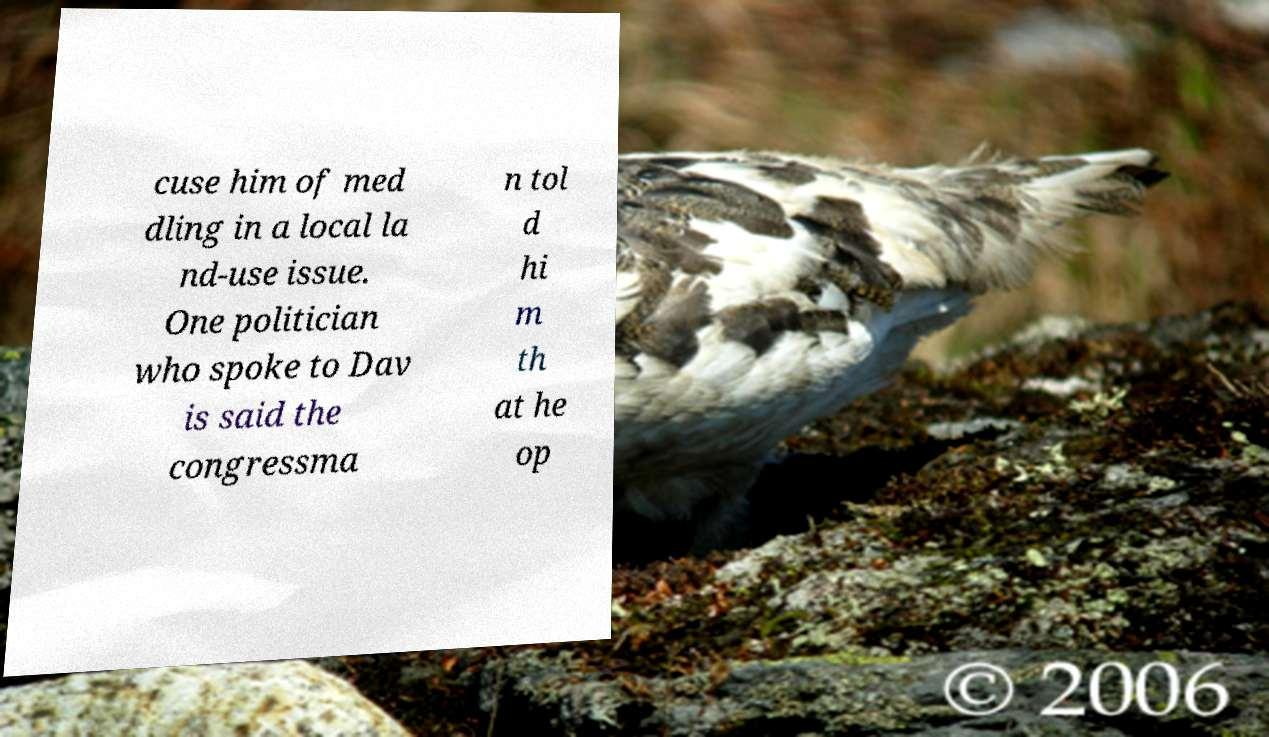What messages or text are displayed in this image? I need them in a readable, typed format. cuse him of med dling in a local la nd-use issue. One politician who spoke to Dav is said the congressma n tol d hi m th at he op 